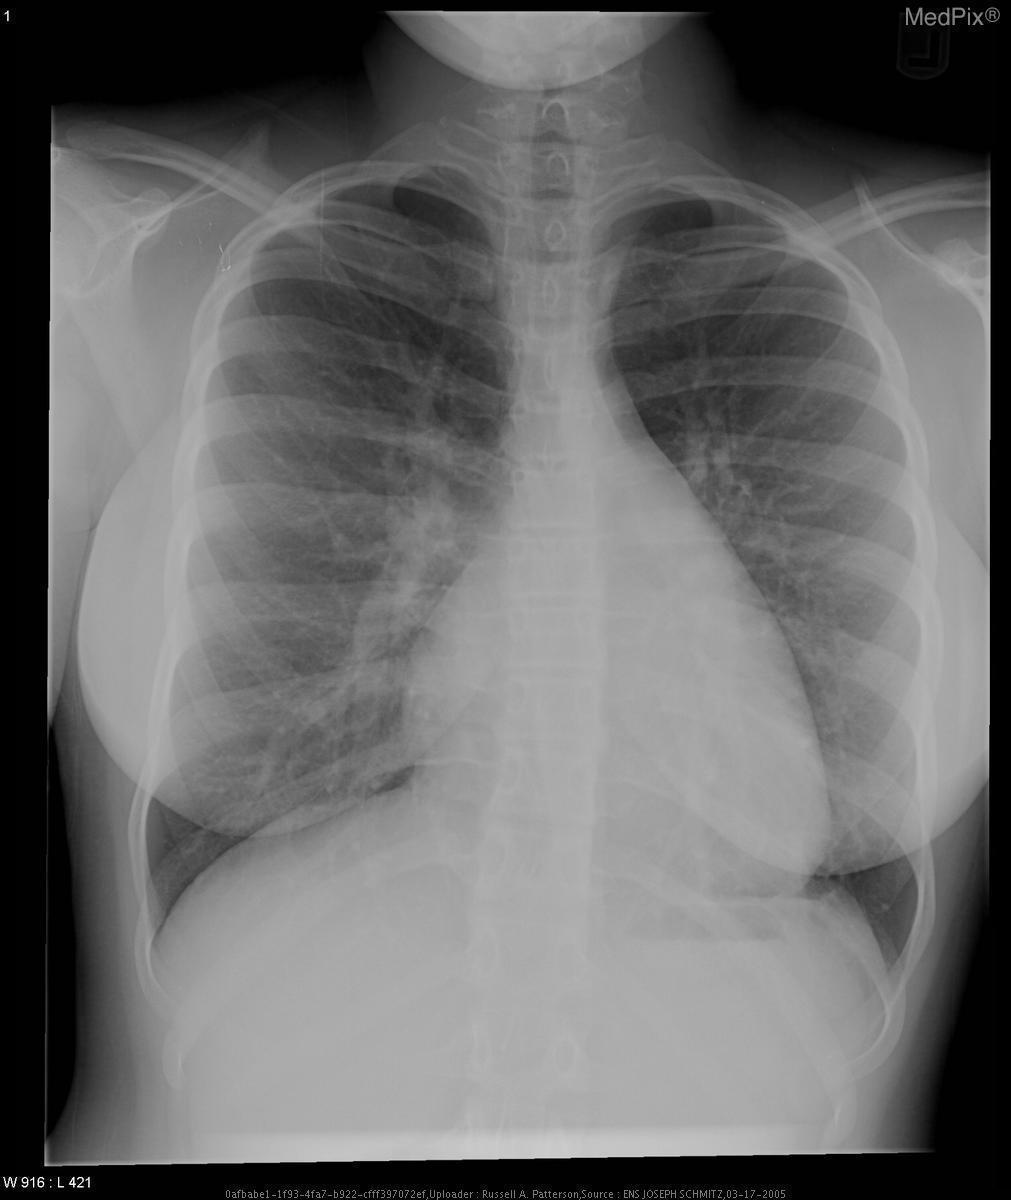Is there cardiac enlargement?
Quick response, please. Yes. Is there a pneumothorax?
Quick response, please. No. Is a pneumothorax present?
Write a very short answer. No. Is the trachea normal?
Short answer required. Yes. Is the trachea midline?
Give a very brief answer. Yes. Is a pleural effusion present?
Short answer required. No. Is there a pleural effusion?
Be succinct. No. 